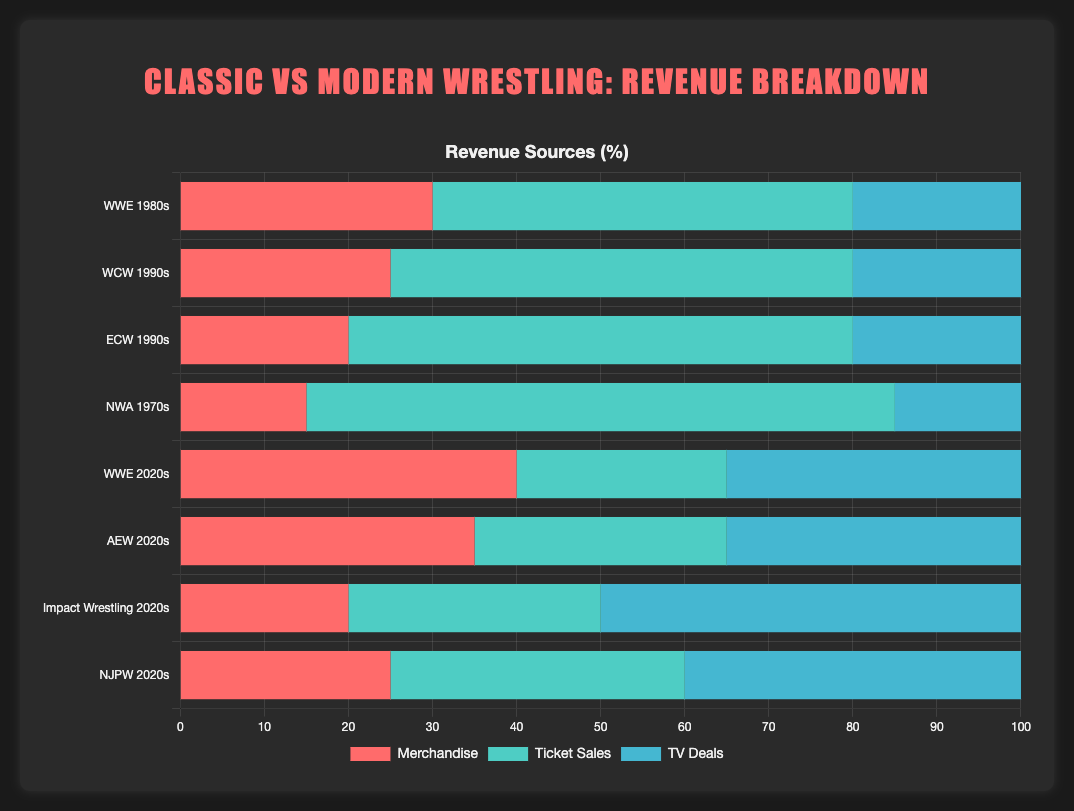What is the main source of revenue for WWE in the 1980s? Observing the length of the bars for the WWE 1980s, the longest bar represents ticket sales.
Answer: Ticket sales Which entity has the highest percentage of revenue from TV deals? Comparing the TV deals bars, Impact Wrestling 2020s has the longest bar for TV deals.
Answer: Impact Wrestling 2020s How do merchandise sales compare between WWE 1980s and WWE 2020s? The merchandise bar for WWE 2020s is longer than that for WWE 1980s. Thus, WWE 2020s has higher merchandise sales.
Answer: WWE 2020s What is the combined percentage of merchandise and ticket sales for AEW 2020s? Adding the two bar lengths for AEW 2020s, merchandise (35) and ticket sales (30), results in a combined percentage of 65.
Answer: 65 Which entity has the smallest proportion of revenue from ticket sales? The shortest ticket sales bar belongs to WWE 2020s with a value of 25.
Answer: WWE 2020s Which classic wrestling entity has the highest total percentage of revenue from merchandise and TV deals combined? Summing up the merchandise and TV deals percentages for classic entities, we get: WWE 1980s (30+20=50), WCW 1990s (25+20=45), ECW 1990s (20+20=40), NWA 1970s (15+15=30). WWE 1980s has the highest combined value.
Answer: WWE 1980s Compare the total percentage of TV deals revenue between all classic and modern wrestling entities. Adding the TV deals revenue percentages: Classic entities sum = 20+20+20+15 = 75, Modern entities sum = 35+35+50+40 = 160. Modern entities have a higher total TV deals revenue percentage.
Answer: Modern Wrestling What is the average percentage of revenue from ticket sales across all classic wrestling entities? Average is found by summing ticket sales for classic entities and dividing by the number of entities: (50+55+60+70)/4 = 235/4 = 58.75.
Answer: 58.75 What is the percentage difference between the highest and lowest merchandise revenues among modern wrestling entities? The highest merchandise revenue among modern entities is WWE 2020s (40), and the lowest is Impact Wrestling 2020s (20). The difference is 40 - 20 = 20.
Answer: 20 